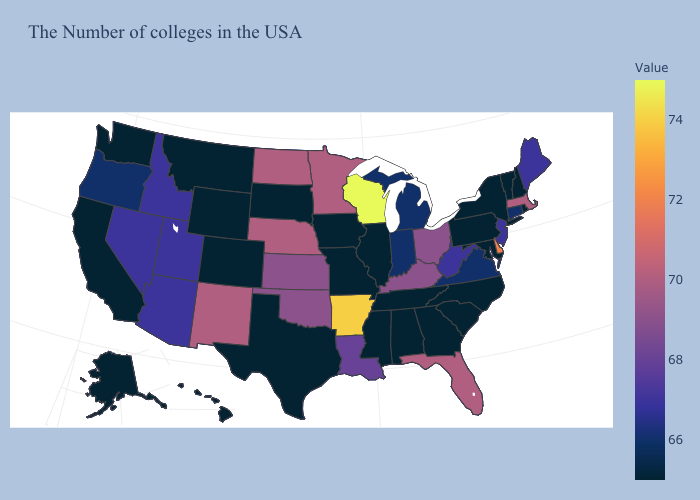Which states hav the highest value in the South?
Concise answer only. Arkansas. Which states have the highest value in the USA?
Give a very brief answer. Wisconsin. Does Wisconsin have the highest value in the MidWest?
Keep it brief. Yes. 